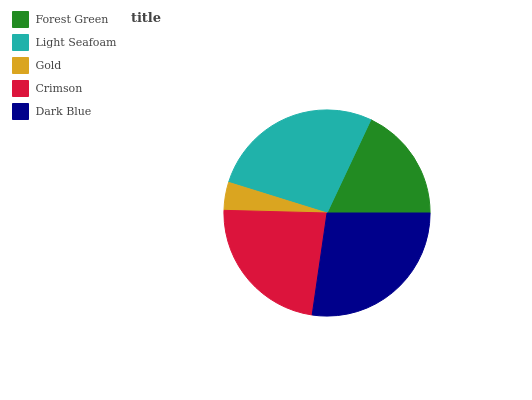Is Gold the minimum?
Answer yes or no. Yes. Is Dark Blue the maximum?
Answer yes or no. Yes. Is Light Seafoam the minimum?
Answer yes or no. No. Is Light Seafoam the maximum?
Answer yes or no. No. Is Light Seafoam greater than Forest Green?
Answer yes or no. Yes. Is Forest Green less than Light Seafoam?
Answer yes or no. Yes. Is Forest Green greater than Light Seafoam?
Answer yes or no. No. Is Light Seafoam less than Forest Green?
Answer yes or no. No. Is Crimson the high median?
Answer yes or no. Yes. Is Crimson the low median?
Answer yes or no. Yes. Is Dark Blue the high median?
Answer yes or no. No. Is Gold the low median?
Answer yes or no. No. 